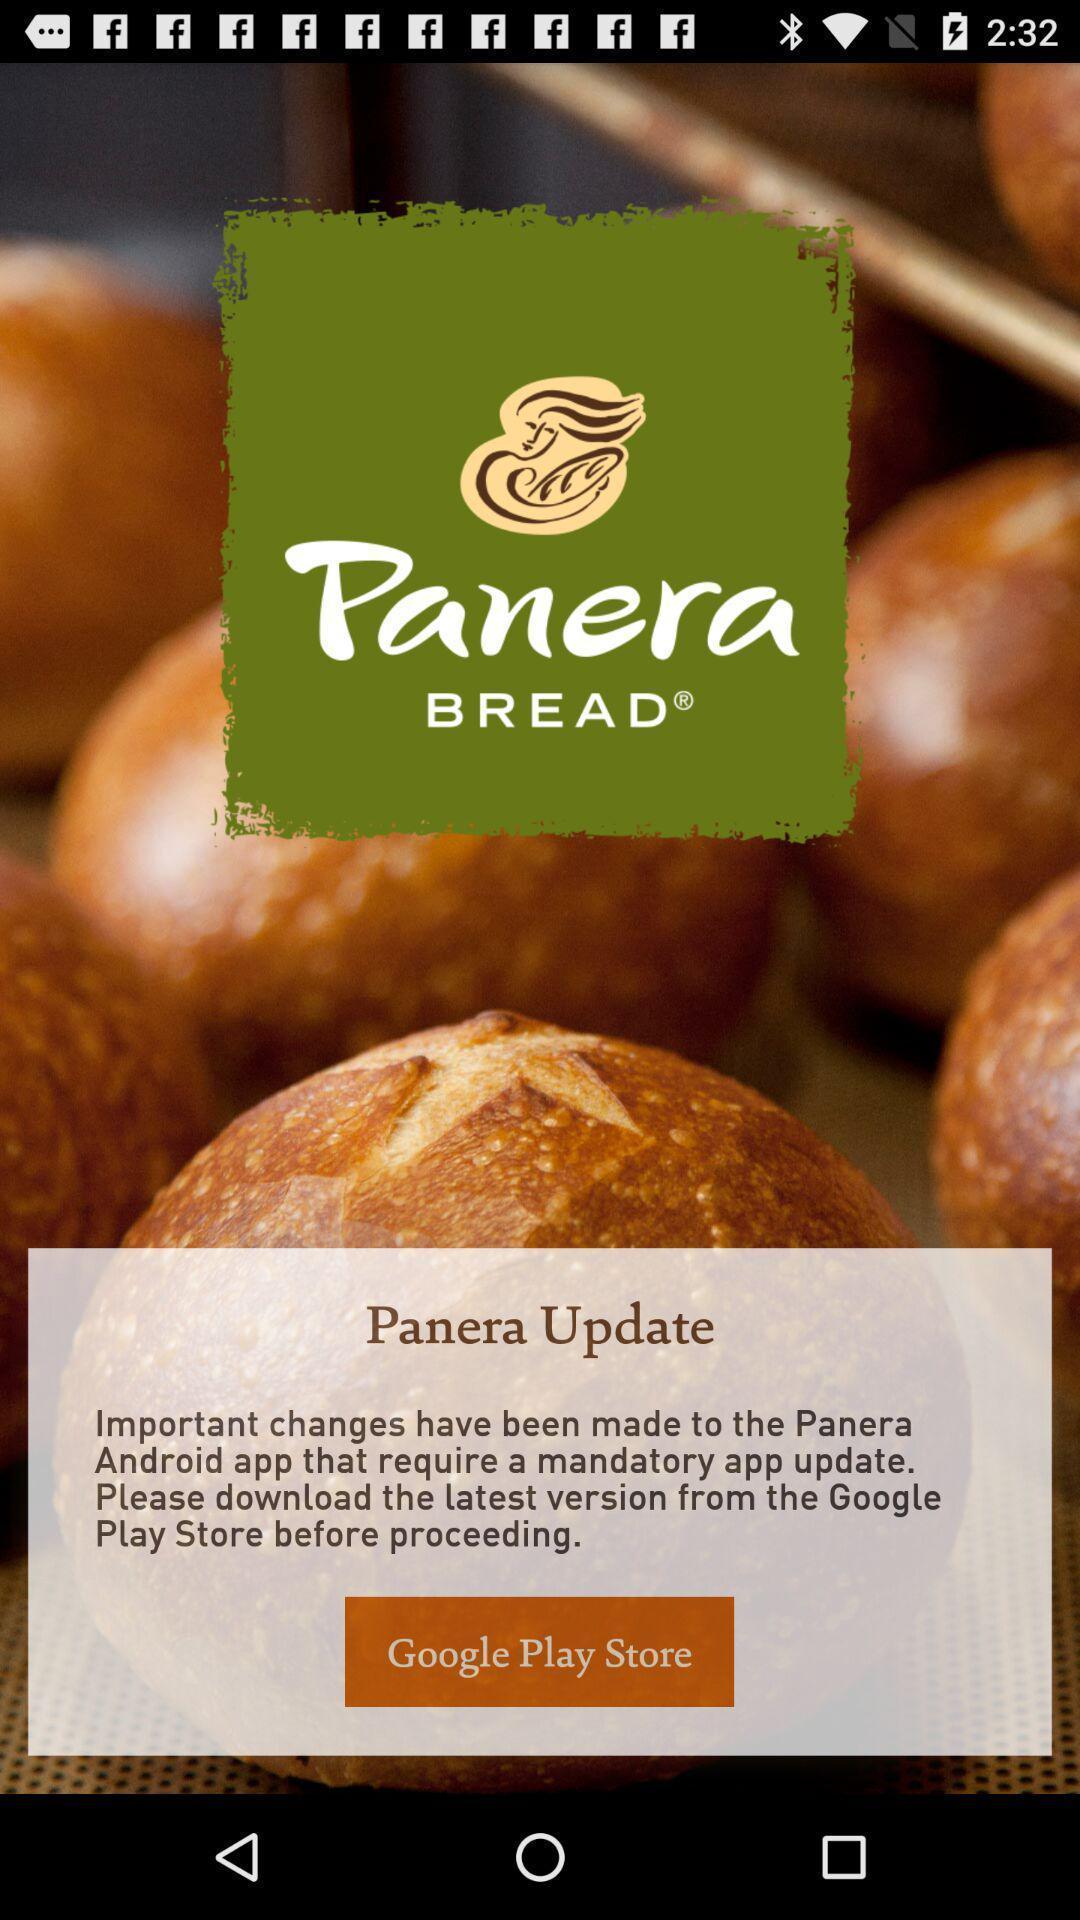Provide a textual representation of this image. Page showing to update the application. 